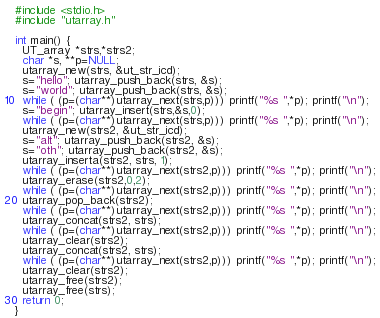<code> <loc_0><loc_0><loc_500><loc_500><_C_>#include <stdio.h>
#include "utarray.h"

int main() {
  UT_array *strs,*strs2;
  char *s, **p=NULL;
  utarray_new(strs, &ut_str_icd);
  s="hello"; utarray_push_back(strs, &s);
  s="world"; utarray_push_back(strs, &s);
  while ( (p=(char**)utarray_next(strs,p))) printf("%s ",*p); printf("\n");
  s="begin"; utarray_insert(strs,&s,0);
  while ( (p=(char**)utarray_next(strs,p))) printf("%s ",*p); printf("\n");
  utarray_new(strs2, &ut_str_icd);
  s="alt"; utarray_push_back(strs2, &s);
  s="oth"; utarray_push_back(strs2, &s);
  utarray_inserta(strs2, strs, 1);
  while ( (p=(char**)utarray_next(strs2,p))) printf("%s ",*p); printf("\n");
  utarray_erase(strs2,0,2);
  while ( (p=(char**)utarray_next(strs2,p))) printf("%s ",*p); printf("\n");
  utarray_pop_back(strs2);
  while ( (p=(char**)utarray_next(strs2,p))) printf("%s ",*p); printf("\n");
  utarray_concat(strs2, strs);
  while ( (p=(char**)utarray_next(strs2,p))) printf("%s ",*p); printf("\n");
  utarray_clear(strs2);
  utarray_concat(strs2, strs);
  while ( (p=(char**)utarray_next(strs2,p))) printf("%s ",*p); printf("\n");
  utarray_clear(strs2);
  utarray_free(strs2);
  utarray_free(strs);
  return 0;
}
</code> 